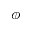Convert formula to latex. <formula><loc_0><loc_0><loc_500><loc_500>\phi</formula> 